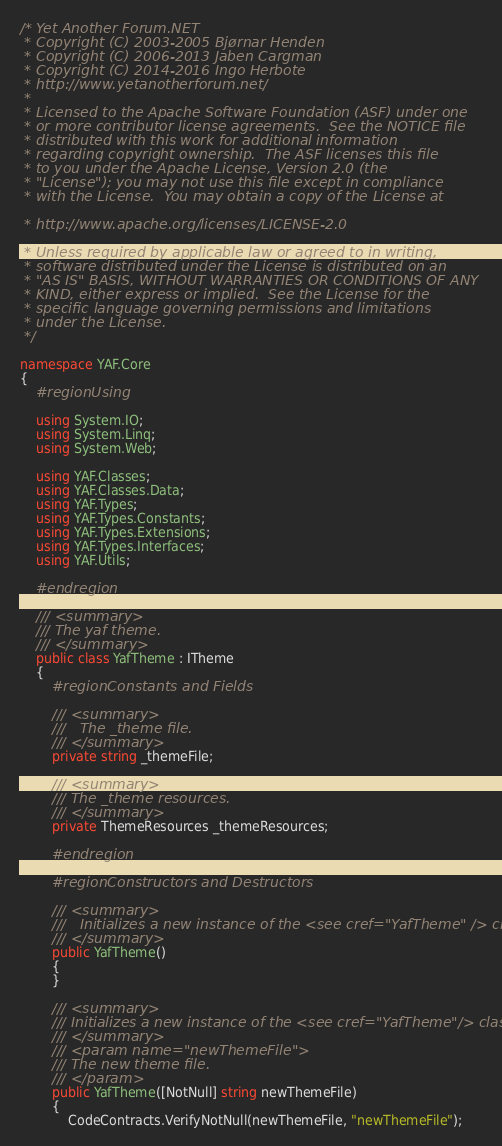<code> <loc_0><loc_0><loc_500><loc_500><_C#_>/* Yet Another Forum.NET
 * Copyright (C) 2003-2005 Bjørnar Henden
 * Copyright (C) 2006-2013 Jaben Cargman
 * Copyright (C) 2014-2016 Ingo Herbote
 * http://www.yetanotherforum.net/
 * 
 * Licensed to the Apache Software Foundation (ASF) under one
 * or more contributor license agreements.  See the NOTICE file
 * distributed with this work for additional information
 * regarding copyright ownership.  The ASF licenses this file
 * to you under the Apache License, Version 2.0 (the
 * "License"); you may not use this file except in compliance
 * with the License.  You may obtain a copy of the License at

 * http://www.apache.org/licenses/LICENSE-2.0

 * Unless required by applicable law or agreed to in writing,
 * software distributed under the License is distributed on an
 * "AS IS" BASIS, WITHOUT WARRANTIES OR CONDITIONS OF ANY
 * KIND, either express or implied.  See the License for the
 * specific language governing permissions and limitations
 * under the License.
 */

namespace YAF.Core
{
    #region Using

    using System.IO;
    using System.Linq;
    using System.Web;

    using YAF.Classes;
    using YAF.Classes.Data;
    using YAF.Types;
    using YAF.Types.Constants;
    using YAF.Types.Extensions;
    using YAF.Types.Interfaces;
    using YAF.Utils;

    #endregion

    /// <summary>
    /// The yaf theme.
    /// </summary>
    public class YafTheme : ITheme
    {
        #region Constants and Fields

        /// <summary>
        ///   The _theme file.
        /// </summary>
        private string _themeFile;

        /// <summary>
        /// The _theme resources.
        /// </summary>
        private ThemeResources _themeResources;

        #endregion

        #region Constructors and Destructors

        /// <summary>
        ///   Initializes a new instance of the <see cref="YafTheme" /> class.
        /// </summary>
        public YafTheme()
        {
        }

        /// <summary>
        /// Initializes a new instance of the <see cref="YafTheme"/> class.
        /// </summary>
        /// <param name="newThemeFile">
        /// The new theme file. 
        /// </param>
        public YafTheme([NotNull] string newThemeFile)
        {
            CodeContracts.VerifyNotNull(newThemeFile, "newThemeFile");
</code> 